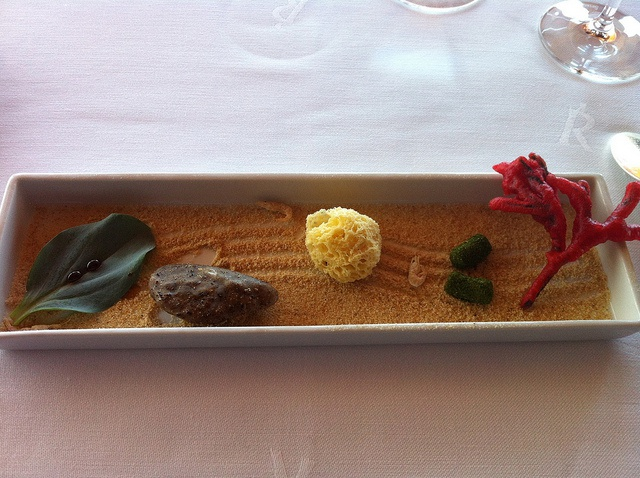Describe the objects in this image and their specific colors. I can see dining table in lavender, gray, brown, and darkgray tones, wine glass in lavender, darkgray, and white tones, and spoon in lavender, white, khaki, and darkgray tones in this image. 